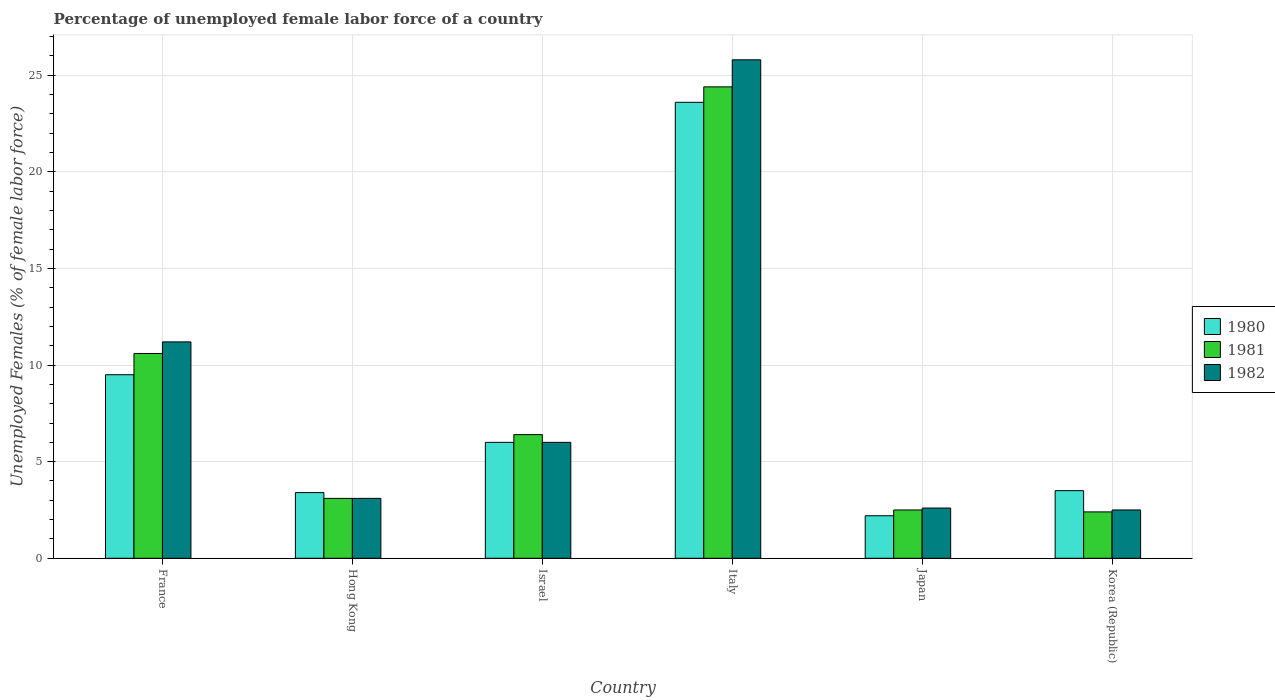How many different coloured bars are there?
Offer a very short reply. 3. Are the number of bars per tick equal to the number of legend labels?
Give a very brief answer. Yes. How many bars are there on the 2nd tick from the right?
Your answer should be compact. 3. In how many cases, is the number of bars for a given country not equal to the number of legend labels?
Keep it short and to the point. 0. Across all countries, what is the maximum percentage of unemployed female labor force in 1981?
Offer a very short reply. 24.4. Across all countries, what is the minimum percentage of unemployed female labor force in 1982?
Offer a terse response. 2.5. In which country was the percentage of unemployed female labor force in 1980 minimum?
Provide a short and direct response. Japan. What is the total percentage of unemployed female labor force in 1980 in the graph?
Your answer should be very brief. 48.2. What is the difference between the percentage of unemployed female labor force in 1981 in France and that in Hong Kong?
Make the answer very short. 7.5. What is the difference between the percentage of unemployed female labor force in 1982 in Israel and the percentage of unemployed female labor force in 1981 in Korea (Republic)?
Provide a succinct answer. 3.6. What is the average percentage of unemployed female labor force in 1980 per country?
Your answer should be very brief. 8.03. In how many countries, is the percentage of unemployed female labor force in 1982 greater than 9 %?
Keep it short and to the point. 2. What is the ratio of the percentage of unemployed female labor force in 1981 in Hong Kong to that in Japan?
Your answer should be compact. 1.24. Is the difference between the percentage of unemployed female labor force in 1980 in Hong Kong and Israel greater than the difference between the percentage of unemployed female labor force in 1982 in Hong Kong and Israel?
Keep it short and to the point. Yes. What is the difference between the highest and the second highest percentage of unemployed female labor force in 1980?
Your answer should be compact. 3.5. What is the difference between the highest and the lowest percentage of unemployed female labor force in 1980?
Make the answer very short. 21.4. In how many countries, is the percentage of unemployed female labor force in 1981 greater than the average percentage of unemployed female labor force in 1981 taken over all countries?
Your answer should be compact. 2. Is the sum of the percentage of unemployed female labor force in 1980 in France and Japan greater than the maximum percentage of unemployed female labor force in 1982 across all countries?
Offer a very short reply. No. Is it the case that in every country, the sum of the percentage of unemployed female labor force in 1981 and percentage of unemployed female labor force in 1982 is greater than the percentage of unemployed female labor force in 1980?
Your response must be concise. Yes. How many bars are there?
Give a very brief answer. 18. Are all the bars in the graph horizontal?
Offer a terse response. No. What is the difference between two consecutive major ticks on the Y-axis?
Make the answer very short. 5. Are the values on the major ticks of Y-axis written in scientific E-notation?
Your answer should be compact. No. Does the graph contain any zero values?
Ensure brevity in your answer.  No. What is the title of the graph?
Make the answer very short. Percentage of unemployed female labor force of a country. Does "1981" appear as one of the legend labels in the graph?
Provide a short and direct response. Yes. What is the label or title of the X-axis?
Make the answer very short. Country. What is the label or title of the Y-axis?
Make the answer very short. Unemployed Females (% of female labor force). What is the Unemployed Females (% of female labor force) of 1981 in France?
Make the answer very short. 10.6. What is the Unemployed Females (% of female labor force) in 1982 in France?
Keep it short and to the point. 11.2. What is the Unemployed Females (% of female labor force) in 1980 in Hong Kong?
Your answer should be very brief. 3.4. What is the Unemployed Females (% of female labor force) in 1981 in Hong Kong?
Provide a short and direct response. 3.1. What is the Unemployed Females (% of female labor force) in 1982 in Hong Kong?
Make the answer very short. 3.1. What is the Unemployed Females (% of female labor force) in 1981 in Israel?
Ensure brevity in your answer.  6.4. What is the Unemployed Females (% of female labor force) in 1982 in Israel?
Offer a terse response. 6. What is the Unemployed Females (% of female labor force) of 1980 in Italy?
Give a very brief answer. 23.6. What is the Unemployed Females (% of female labor force) of 1981 in Italy?
Your answer should be compact. 24.4. What is the Unemployed Females (% of female labor force) in 1982 in Italy?
Give a very brief answer. 25.8. What is the Unemployed Females (% of female labor force) in 1980 in Japan?
Offer a very short reply. 2.2. What is the Unemployed Females (% of female labor force) in 1981 in Japan?
Offer a very short reply. 2.5. What is the Unemployed Females (% of female labor force) in 1982 in Japan?
Your response must be concise. 2.6. What is the Unemployed Females (% of female labor force) in 1980 in Korea (Republic)?
Your answer should be compact. 3.5. What is the Unemployed Females (% of female labor force) of 1981 in Korea (Republic)?
Your answer should be very brief. 2.4. What is the Unemployed Females (% of female labor force) in 1982 in Korea (Republic)?
Offer a terse response. 2.5. Across all countries, what is the maximum Unemployed Females (% of female labor force) in 1980?
Provide a short and direct response. 23.6. Across all countries, what is the maximum Unemployed Females (% of female labor force) of 1981?
Offer a terse response. 24.4. Across all countries, what is the maximum Unemployed Females (% of female labor force) of 1982?
Provide a succinct answer. 25.8. Across all countries, what is the minimum Unemployed Females (% of female labor force) in 1980?
Your answer should be compact. 2.2. Across all countries, what is the minimum Unemployed Females (% of female labor force) in 1981?
Keep it short and to the point. 2.4. Across all countries, what is the minimum Unemployed Females (% of female labor force) of 1982?
Ensure brevity in your answer.  2.5. What is the total Unemployed Females (% of female labor force) of 1980 in the graph?
Your answer should be very brief. 48.2. What is the total Unemployed Females (% of female labor force) in 1981 in the graph?
Your answer should be compact. 49.4. What is the total Unemployed Females (% of female labor force) of 1982 in the graph?
Offer a very short reply. 51.2. What is the difference between the Unemployed Females (% of female labor force) of 1981 in France and that in Hong Kong?
Provide a short and direct response. 7.5. What is the difference between the Unemployed Females (% of female labor force) in 1982 in France and that in Hong Kong?
Offer a terse response. 8.1. What is the difference between the Unemployed Females (% of female labor force) of 1981 in France and that in Israel?
Offer a terse response. 4.2. What is the difference between the Unemployed Females (% of female labor force) in 1982 in France and that in Israel?
Your answer should be very brief. 5.2. What is the difference between the Unemployed Females (% of female labor force) of 1980 in France and that in Italy?
Your answer should be very brief. -14.1. What is the difference between the Unemployed Females (% of female labor force) in 1981 in France and that in Italy?
Your response must be concise. -13.8. What is the difference between the Unemployed Females (% of female labor force) of 1982 in France and that in Italy?
Your answer should be compact. -14.6. What is the difference between the Unemployed Females (% of female labor force) of 1981 in France and that in Japan?
Your answer should be very brief. 8.1. What is the difference between the Unemployed Females (% of female labor force) in 1982 in France and that in Japan?
Offer a terse response. 8.6. What is the difference between the Unemployed Females (% of female labor force) of 1980 in France and that in Korea (Republic)?
Make the answer very short. 6. What is the difference between the Unemployed Females (% of female labor force) in 1981 in France and that in Korea (Republic)?
Your answer should be compact. 8.2. What is the difference between the Unemployed Females (% of female labor force) of 1981 in Hong Kong and that in Israel?
Your answer should be compact. -3.3. What is the difference between the Unemployed Females (% of female labor force) of 1980 in Hong Kong and that in Italy?
Your answer should be compact. -20.2. What is the difference between the Unemployed Females (% of female labor force) in 1981 in Hong Kong and that in Italy?
Keep it short and to the point. -21.3. What is the difference between the Unemployed Females (% of female labor force) in 1982 in Hong Kong and that in Italy?
Your response must be concise. -22.7. What is the difference between the Unemployed Females (% of female labor force) of 1980 in Hong Kong and that in Japan?
Provide a succinct answer. 1.2. What is the difference between the Unemployed Females (% of female labor force) of 1981 in Hong Kong and that in Japan?
Offer a terse response. 0.6. What is the difference between the Unemployed Females (% of female labor force) in 1980 in Hong Kong and that in Korea (Republic)?
Ensure brevity in your answer.  -0.1. What is the difference between the Unemployed Females (% of female labor force) in 1981 in Hong Kong and that in Korea (Republic)?
Provide a succinct answer. 0.7. What is the difference between the Unemployed Females (% of female labor force) of 1980 in Israel and that in Italy?
Give a very brief answer. -17.6. What is the difference between the Unemployed Females (% of female labor force) of 1981 in Israel and that in Italy?
Your answer should be very brief. -18. What is the difference between the Unemployed Females (% of female labor force) of 1982 in Israel and that in Italy?
Keep it short and to the point. -19.8. What is the difference between the Unemployed Females (% of female labor force) in 1982 in Israel and that in Japan?
Provide a short and direct response. 3.4. What is the difference between the Unemployed Females (% of female labor force) in 1980 in Italy and that in Japan?
Provide a succinct answer. 21.4. What is the difference between the Unemployed Females (% of female labor force) in 1981 in Italy and that in Japan?
Offer a terse response. 21.9. What is the difference between the Unemployed Females (% of female labor force) in 1982 in Italy and that in Japan?
Provide a succinct answer. 23.2. What is the difference between the Unemployed Females (% of female labor force) of 1980 in Italy and that in Korea (Republic)?
Provide a succinct answer. 20.1. What is the difference between the Unemployed Females (% of female labor force) of 1982 in Italy and that in Korea (Republic)?
Your answer should be very brief. 23.3. What is the difference between the Unemployed Females (% of female labor force) in 1981 in Japan and that in Korea (Republic)?
Ensure brevity in your answer.  0.1. What is the difference between the Unemployed Females (% of female labor force) in 1980 in France and the Unemployed Females (% of female labor force) in 1982 in Hong Kong?
Provide a short and direct response. 6.4. What is the difference between the Unemployed Females (% of female labor force) in 1981 in France and the Unemployed Females (% of female labor force) in 1982 in Hong Kong?
Your answer should be very brief. 7.5. What is the difference between the Unemployed Females (% of female labor force) of 1981 in France and the Unemployed Females (% of female labor force) of 1982 in Israel?
Offer a terse response. 4.6. What is the difference between the Unemployed Females (% of female labor force) of 1980 in France and the Unemployed Females (% of female labor force) of 1981 in Italy?
Your response must be concise. -14.9. What is the difference between the Unemployed Females (% of female labor force) in 1980 in France and the Unemployed Females (% of female labor force) in 1982 in Italy?
Give a very brief answer. -16.3. What is the difference between the Unemployed Females (% of female labor force) in 1981 in France and the Unemployed Females (% of female labor force) in 1982 in Italy?
Make the answer very short. -15.2. What is the difference between the Unemployed Females (% of female labor force) in 1980 in France and the Unemployed Females (% of female labor force) in 1982 in Japan?
Provide a short and direct response. 6.9. What is the difference between the Unemployed Females (% of female labor force) of 1981 in France and the Unemployed Females (% of female labor force) of 1982 in Japan?
Ensure brevity in your answer.  8. What is the difference between the Unemployed Females (% of female labor force) of 1980 in France and the Unemployed Females (% of female labor force) of 1982 in Korea (Republic)?
Make the answer very short. 7. What is the difference between the Unemployed Females (% of female labor force) in 1981 in France and the Unemployed Females (% of female labor force) in 1982 in Korea (Republic)?
Ensure brevity in your answer.  8.1. What is the difference between the Unemployed Females (% of female labor force) of 1980 in Hong Kong and the Unemployed Females (% of female labor force) of 1981 in Israel?
Provide a short and direct response. -3. What is the difference between the Unemployed Females (% of female labor force) in 1980 in Hong Kong and the Unemployed Females (% of female labor force) in 1982 in Italy?
Provide a succinct answer. -22.4. What is the difference between the Unemployed Females (% of female labor force) of 1981 in Hong Kong and the Unemployed Females (% of female labor force) of 1982 in Italy?
Make the answer very short. -22.7. What is the difference between the Unemployed Females (% of female labor force) of 1980 in Hong Kong and the Unemployed Females (% of female labor force) of 1981 in Korea (Republic)?
Offer a very short reply. 1. What is the difference between the Unemployed Females (% of female labor force) of 1980 in Hong Kong and the Unemployed Females (% of female labor force) of 1982 in Korea (Republic)?
Your response must be concise. 0.9. What is the difference between the Unemployed Females (% of female labor force) of 1980 in Israel and the Unemployed Females (% of female labor force) of 1981 in Italy?
Provide a succinct answer. -18.4. What is the difference between the Unemployed Females (% of female labor force) of 1980 in Israel and the Unemployed Females (% of female labor force) of 1982 in Italy?
Offer a terse response. -19.8. What is the difference between the Unemployed Females (% of female labor force) in 1981 in Israel and the Unemployed Females (% of female labor force) in 1982 in Italy?
Your answer should be very brief. -19.4. What is the difference between the Unemployed Females (% of female labor force) in 1980 in Israel and the Unemployed Females (% of female labor force) in 1981 in Japan?
Provide a short and direct response. 3.5. What is the difference between the Unemployed Females (% of female labor force) in 1980 in Israel and the Unemployed Females (% of female labor force) in 1982 in Japan?
Keep it short and to the point. 3.4. What is the difference between the Unemployed Females (% of female labor force) in 1981 in Israel and the Unemployed Females (% of female labor force) in 1982 in Japan?
Offer a terse response. 3.8. What is the difference between the Unemployed Females (% of female labor force) in 1980 in Israel and the Unemployed Females (% of female labor force) in 1981 in Korea (Republic)?
Your answer should be compact. 3.6. What is the difference between the Unemployed Females (% of female labor force) of 1980 in Italy and the Unemployed Females (% of female labor force) of 1981 in Japan?
Your response must be concise. 21.1. What is the difference between the Unemployed Females (% of female labor force) in 1981 in Italy and the Unemployed Females (% of female labor force) in 1982 in Japan?
Provide a succinct answer. 21.8. What is the difference between the Unemployed Females (% of female labor force) in 1980 in Italy and the Unemployed Females (% of female labor force) in 1981 in Korea (Republic)?
Give a very brief answer. 21.2. What is the difference between the Unemployed Females (% of female labor force) in 1980 in Italy and the Unemployed Females (% of female labor force) in 1982 in Korea (Republic)?
Your response must be concise. 21.1. What is the difference between the Unemployed Females (% of female labor force) in 1981 in Italy and the Unemployed Females (% of female labor force) in 1982 in Korea (Republic)?
Provide a succinct answer. 21.9. What is the difference between the Unemployed Females (% of female labor force) in 1980 in Japan and the Unemployed Females (% of female labor force) in 1981 in Korea (Republic)?
Your response must be concise. -0.2. What is the difference between the Unemployed Females (% of female labor force) of 1981 in Japan and the Unemployed Females (% of female labor force) of 1982 in Korea (Republic)?
Your answer should be very brief. 0. What is the average Unemployed Females (% of female labor force) of 1980 per country?
Provide a succinct answer. 8.03. What is the average Unemployed Females (% of female labor force) of 1981 per country?
Ensure brevity in your answer.  8.23. What is the average Unemployed Females (% of female labor force) in 1982 per country?
Keep it short and to the point. 8.53. What is the difference between the Unemployed Females (% of female labor force) of 1980 and Unemployed Females (% of female labor force) of 1982 in France?
Provide a succinct answer. -1.7. What is the difference between the Unemployed Females (% of female labor force) of 1981 and Unemployed Females (% of female labor force) of 1982 in France?
Your response must be concise. -0.6. What is the difference between the Unemployed Females (% of female labor force) in 1980 and Unemployed Females (% of female labor force) in 1981 in Hong Kong?
Offer a very short reply. 0.3. What is the difference between the Unemployed Females (% of female labor force) in 1980 and Unemployed Females (% of female labor force) in 1982 in Hong Kong?
Make the answer very short. 0.3. What is the difference between the Unemployed Females (% of female labor force) in 1980 and Unemployed Females (% of female labor force) in 1982 in Israel?
Give a very brief answer. 0. What is the difference between the Unemployed Females (% of female labor force) in 1981 and Unemployed Females (% of female labor force) in 1982 in Israel?
Your answer should be compact. 0.4. What is the difference between the Unemployed Females (% of female labor force) in 1981 and Unemployed Females (% of female labor force) in 1982 in Italy?
Ensure brevity in your answer.  -1.4. What is the difference between the Unemployed Females (% of female labor force) in 1980 and Unemployed Females (% of female labor force) in 1981 in Japan?
Your answer should be very brief. -0.3. What is the difference between the Unemployed Females (% of female labor force) in 1980 and Unemployed Females (% of female labor force) in 1982 in Japan?
Your answer should be compact. -0.4. What is the difference between the Unemployed Females (% of female labor force) in 1980 and Unemployed Females (% of female labor force) in 1981 in Korea (Republic)?
Your response must be concise. 1.1. What is the difference between the Unemployed Females (% of female labor force) of 1981 and Unemployed Females (% of female labor force) of 1982 in Korea (Republic)?
Provide a short and direct response. -0.1. What is the ratio of the Unemployed Females (% of female labor force) in 1980 in France to that in Hong Kong?
Your response must be concise. 2.79. What is the ratio of the Unemployed Females (% of female labor force) in 1981 in France to that in Hong Kong?
Provide a succinct answer. 3.42. What is the ratio of the Unemployed Females (% of female labor force) of 1982 in France to that in Hong Kong?
Your answer should be compact. 3.61. What is the ratio of the Unemployed Females (% of female labor force) in 1980 in France to that in Israel?
Provide a short and direct response. 1.58. What is the ratio of the Unemployed Females (% of female labor force) in 1981 in France to that in Israel?
Your answer should be compact. 1.66. What is the ratio of the Unemployed Females (% of female labor force) in 1982 in France to that in Israel?
Your response must be concise. 1.87. What is the ratio of the Unemployed Females (% of female labor force) of 1980 in France to that in Italy?
Give a very brief answer. 0.4. What is the ratio of the Unemployed Females (% of female labor force) in 1981 in France to that in Italy?
Give a very brief answer. 0.43. What is the ratio of the Unemployed Females (% of female labor force) of 1982 in France to that in Italy?
Give a very brief answer. 0.43. What is the ratio of the Unemployed Females (% of female labor force) in 1980 in France to that in Japan?
Ensure brevity in your answer.  4.32. What is the ratio of the Unemployed Females (% of female labor force) in 1981 in France to that in Japan?
Your answer should be very brief. 4.24. What is the ratio of the Unemployed Females (% of female labor force) of 1982 in France to that in Japan?
Your answer should be compact. 4.31. What is the ratio of the Unemployed Females (% of female labor force) in 1980 in France to that in Korea (Republic)?
Offer a very short reply. 2.71. What is the ratio of the Unemployed Females (% of female labor force) in 1981 in France to that in Korea (Republic)?
Offer a very short reply. 4.42. What is the ratio of the Unemployed Females (% of female labor force) in 1982 in France to that in Korea (Republic)?
Offer a very short reply. 4.48. What is the ratio of the Unemployed Females (% of female labor force) in 1980 in Hong Kong to that in Israel?
Your answer should be compact. 0.57. What is the ratio of the Unemployed Females (% of female labor force) of 1981 in Hong Kong to that in Israel?
Make the answer very short. 0.48. What is the ratio of the Unemployed Females (% of female labor force) in 1982 in Hong Kong to that in Israel?
Provide a short and direct response. 0.52. What is the ratio of the Unemployed Females (% of female labor force) of 1980 in Hong Kong to that in Italy?
Your answer should be very brief. 0.14. What is the ratio of the Unemployed Females (% of female labor force) of 1981 in Hong Kong to that in Italy?
Your answer should be very brief. 0.13. What is the ratio of the Unemployed Females (% of female labor force) in 1982 in Hong Kong to that in Italy?
Give a very brief answer. 0.12. What is the ratio of the Unemployed Females (% of female labor force) in 1980 in Hong Kong to that in Japan?
Your answer should be compact. 1.55. What is the ratio of the Unemployed Females (% of female labor force) of 1981 in Hong Kong to that in Japan?
Make the answer very short. 1.24. What is the ratio of the Unemployed Females (% of female labor force) in 1982 in Hong Kong to that in Japan?
Offer a very short reply. 1.19. What is the ratio of the Unemployed Females (% of female labor force) of 1980 in Hong Kong to that in Korea (Republic)?
Provide a succinct answer. 0.97. What is the ratio of the Unemployed Females (% of female labor force) in 1981 in Hong Kong to that in Korea (Republic)?
Your answer should be very brief. 1.29. What is the ratio of the Unemployed Females (% of female labor force) in 1982 in Hong Kong to that in Korea (Republic)?
Keep it short and to the point. 1.24. What is the ratio of the Unemployed Females (% of female labor force) of 1980 in Israel to that in Italy?
Your answer should be very brief. 0.25. What is the ratio of the Unemployed Females (% of female labor force) of 1981 in Israel to that in Italy?
Provide a succinct answer. 0.26. What is the ratio of the Unemployed Females (% of female labor force) of 1982 in Israel to that in Italy?
Provide a short and direct response. 0.23. What is the ratio of the Unemployed Females (% of female labor force) in 1980 in Israel to that in Japan?
Offer a terse response. 2.73. What is the ratio of the Unemployed Females (% of female labor force) in 1981 in Israel to that in Japan?
Your response must be concise. 2.56. What is the ratio of the Unemployed Females (% of female labor force) in 1982 in Israel to that in Japan?
Give a very brief answer. 2.31. What is the ratio of the Unemployed Females (% of female labor force) of 1980 in Israel to that in Korea (Republic)?
Provide a succinct answer. 1.71. What is the ratio of the Unemployed Females (% of female labor force) in 1981 in Israel to that in Korea (Republic)?
Provide a succinct answer. 2.67. What is the ratio of the Unemployed Females (% of female labor force) of 1980 in Italy to that in Japan?
Your answer should be compact. 10.73. What is the ratio of the Unemployed Females (% of female labor force) in 1981 in Italy to that in Japan?
Your answer should be compact. 9.76. What is the ratio of the Unemployed Females (% of female labor force) in 1982 in Italy to that in Japan?
Your response must be concise. 9.92. What is the ratio of the Unemployed Females (% of female labor force) in 1980 in Italy to that in Korea (Republic)?
Your answer should be compact. 6.74. What is the ratio of the Unemployed Females (% of female labor force) in 1981 in Italy to that in Korea (Republic)?
Ensure brevity in your answer.  10.17. What is the ratio of the Unemployed Females (% of female labor force) of 1982 in Italy to that in Korea (Republic)?
Your response must be concise. 10.32. What is the ratio of the Unemployed Females (% of female labor force) in 1980 in Japan to that in Korea (Republic)?
Provide a short and direct response. 0.63. What is the ratio of the Unemployed Females (% of female labor force) of 1981 in Japan to that in Korea (Republic)?
Provide a succinct answer. 1.04. What is the ratio of the Unemployed Females (% of female labor force) of 1982 in Japan to that in Korea (Republic)?
Your response must be concise. 1.04. What is the difference between the highest and the second highest Unemployed Females (% of female labor force) of 1980?
Offer a very short reply. 14.1. What is the difference between the highest and the second highest Unemployed Females (% of female labor force) of 1981?
Your response must be concise. 13.8. What is the difference between the highest and the second highest Unemployed Females (% of female labor force) of 1982?
Provide a short and direct response. 14.6. What is the difference between the highest and the lowest Unemployed Females (% of female labor force) of 1980?
Offer a terse response. 21.4. What is the difference between the highest and the lowest Unemployed Females (% of female labor force) of 1981?
Offer a terse response. 22. What is the difference between the highest and the lowest Unemployed Females (% of female labor force) of 1982?
Offer a very short reply. 23.3. 